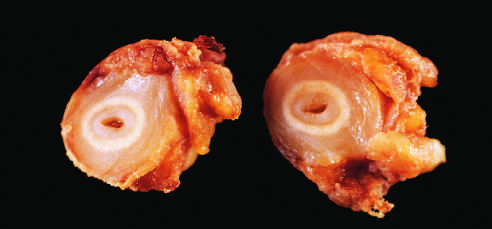what correspond to the original vessel wall?
Answer the question using a single word or phrase. The white circles 